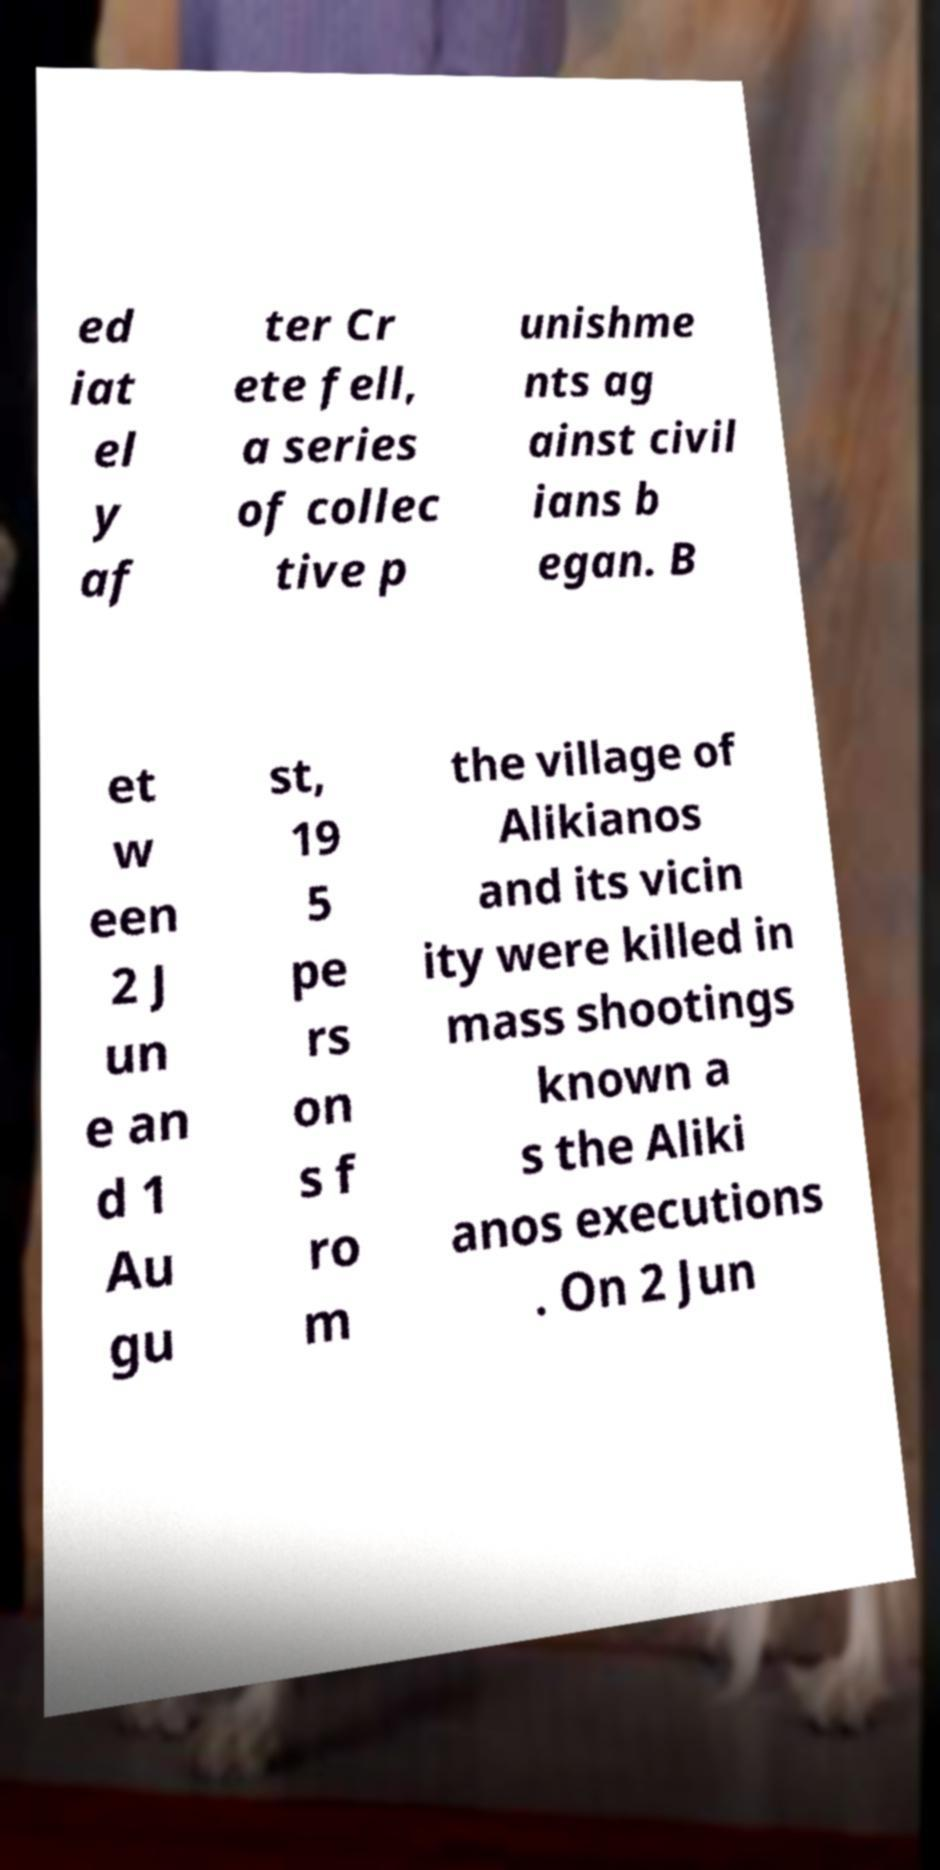What messages or text are displayed in this image? I need them in a readable, typed format. ed iat el y af ter Cr ete fell, a series of collec tive p unishme nts ag ainst civil ians b egan. B et w een 2 J un e an d 1 Au gu st, 19 5 pe rs on s f ro m the village of Alikianos and its vicin ity were killed in mass shootings known a s the Aliki anos executions . On 2 Jun 